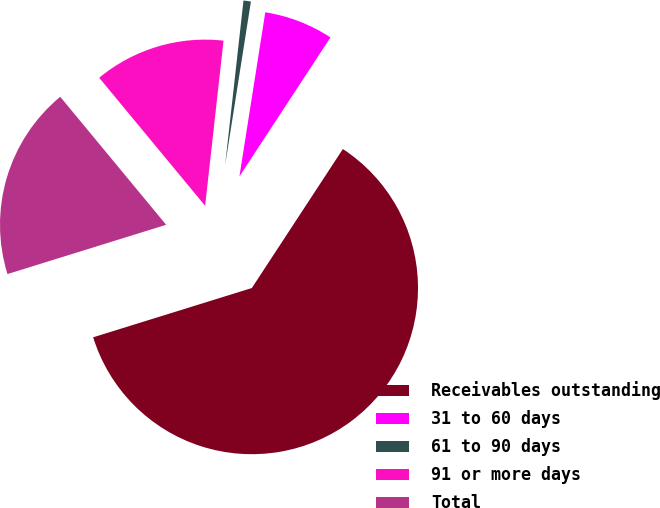Convert chart to OTSL. <chart><loc_0><loc_0><loc_500><loc_500><pie_chart><fcel>Receivables outstanding<fcel>31 to 60 days<fcel>61 to 90 days<fcel>91 or more days<fcel>Total<nl><fcel>60.98%<fcel>6.74%<fcel>0.72%<fcel>12.77%<fcel>18.79%<nl></chart> 